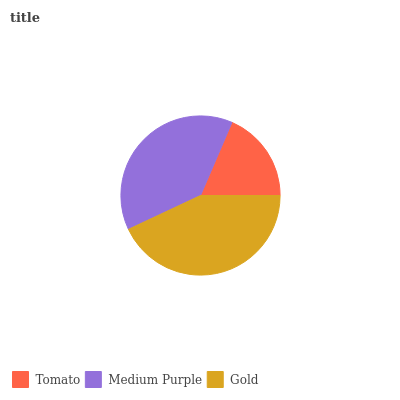Is Tomato the minimum?
Answer yes or no. Yes. Is Gold the maximum?
Answer yes or no. Yes. Is Medium Purple the minimum?
Answer yes or no. No. Is Medium Purple the maximum?
Answer yes or no. No. Is Medium Purple greater than Tomato?
Answer yes or no. Yes. Is Tomato less than Medium Purple?
Answer yes or no. Yes. Is Tomato greater than Medium Purple?
Answer yes or no. No. Is Medium Purple less than Tomato?
Answer yes or no. No. Is Medium Purple the high median?
Answer yes or no. Yes. Is Medium Purple the low median?
Answer yes or no. Yes. Is Gold the high median?
Answer yes or no. No. Is Tomato the low median?
Answer yes or no. No. 